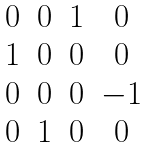<formula> <loc_0><loc_0><loc_500><loc_500>\begin{matrix} 0 & 0 & 1 & 0 \\ 1 & 0 & 0 & 0 \\ 0 & 0 & 0 & - 1 \\ 0 & 1 & 0 & 0 \end{matrix}</formula> 